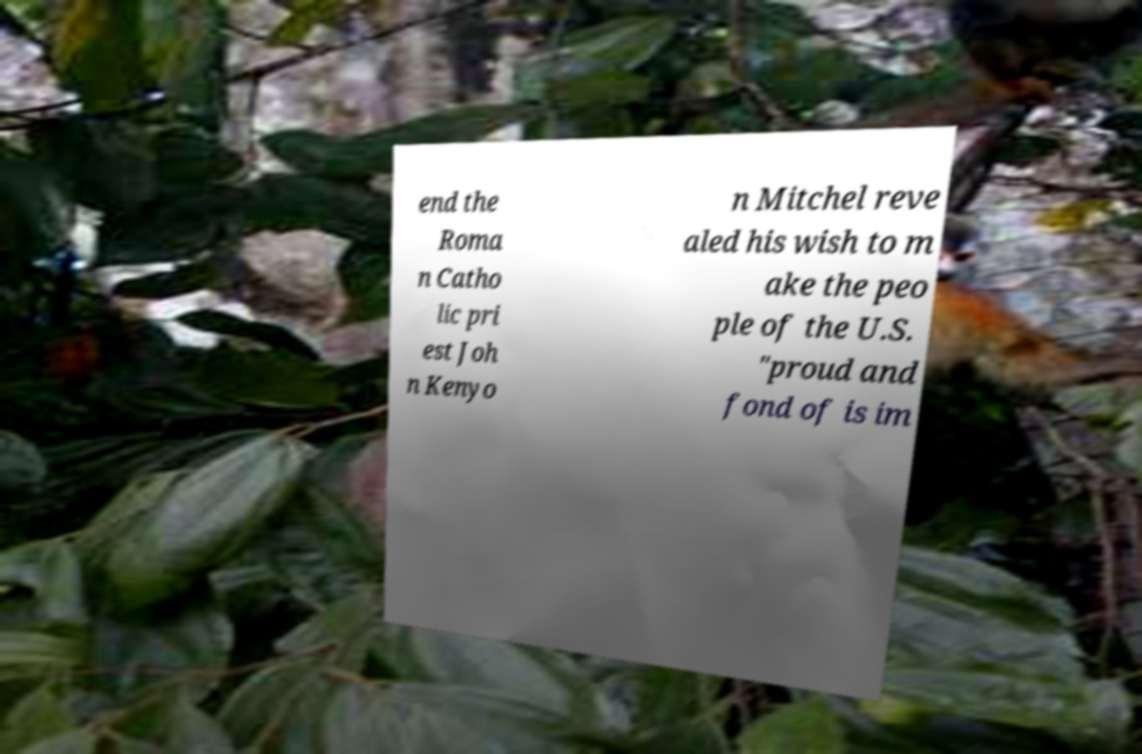What messages or text are displayed in this image? I need them in a readable, typed format. end the Roma n Catho lic pri est Joh n Kenyo n Mitchel reve aled his wish to m ake the peo ple of the U.S. "proud and fond of is im 